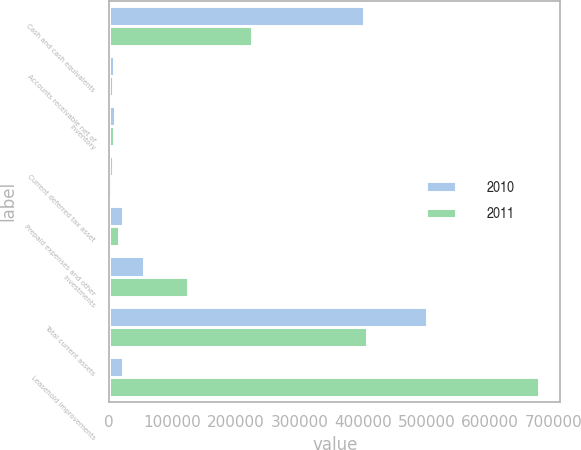Convert chart. <chart><loc_0><loc_0><loc_500><loc_500><stacked_bar_chart><ecel><fcel>Cash and cash equivalents<fcel>Accounts receivable net of<fcel>Inventory<fcel>Current deferred tax asset<fcel>Prepaid expenses and other<fcel>Investments<fcel>Total current assets<fcel>Leasehold improvements<nl><fcel>2010<fcel>401243<fcel>8389<fcel>8913<fcel>6238<fcel>21404<fcel>55005<fcel>501192<fcel>21404<nl><fcel>2011<fcel>224838<fcel>5658<fcel>7098<fcel>4317<fcel>16016<fcel>124766<fcel>406221<fcel>676881<nl></chart> 